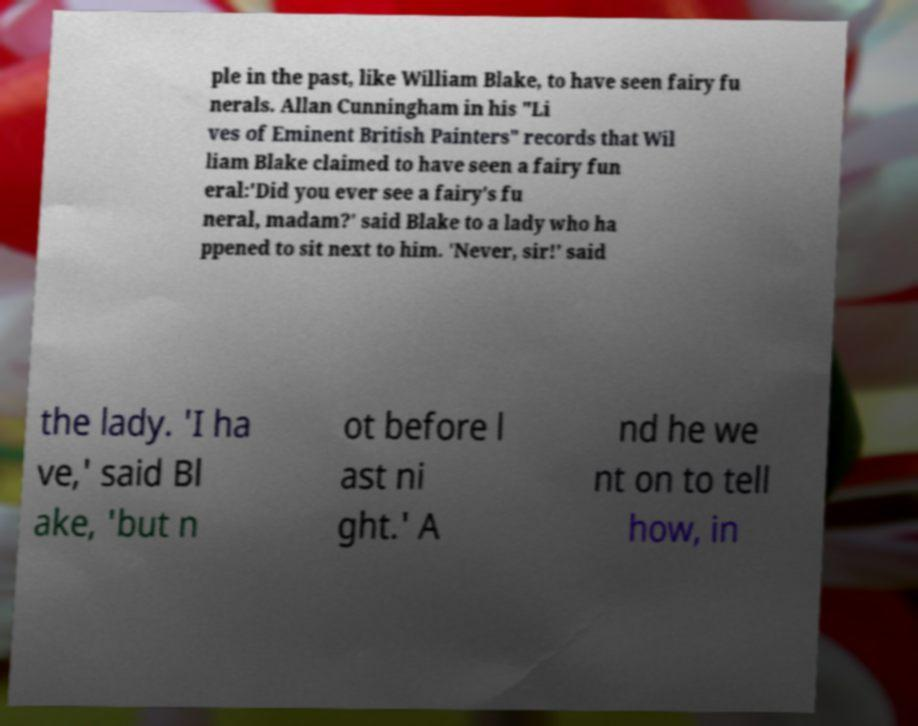There's text embedded in this image that I need extracted. Can you transcribe it verbatim? ple in the past, like William Blake, to have seen fairy fu nerals. Allan Cunningham in his "Li ves of Eminent British Painters" records that Wil liam Blake claimed to have seen a fairy fun eral:'Did you ever see a fairy's fu neral, madam?' said Blake to a lady who ha ppened to sit next to him. 'Never, sir!' said the lady. 'I ha ve,' said Bl ake, 'but n ot before l ast ni ght.' A nd he we nt on to tell how, in 